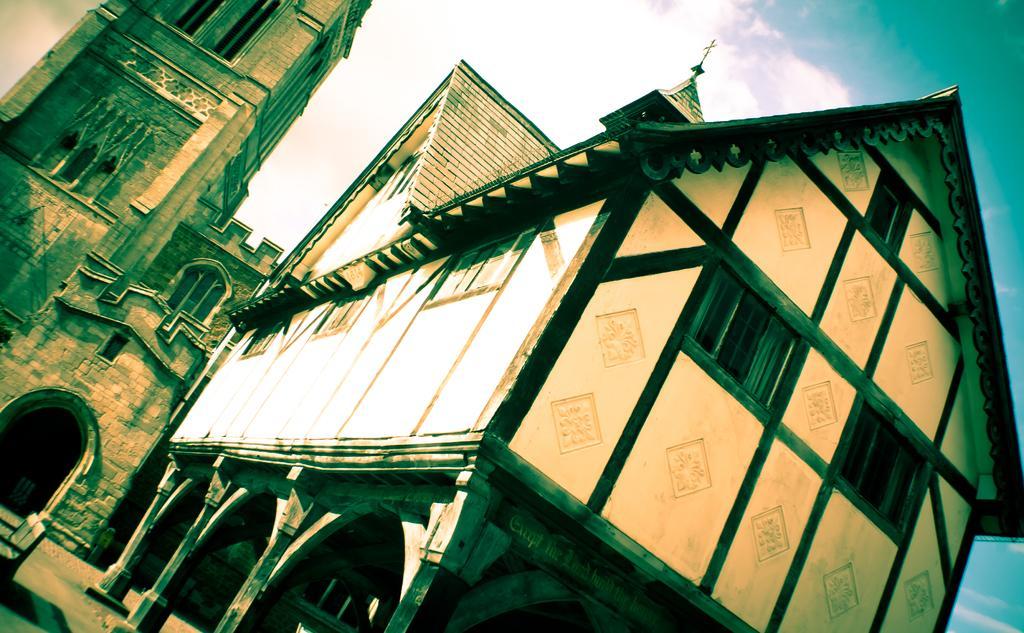In one or two sentences, can you explain what this image depicts? On the right side, there is a building having roof and windows. In the background, there is a building which is having windows and there are clouds in the blue sky. 